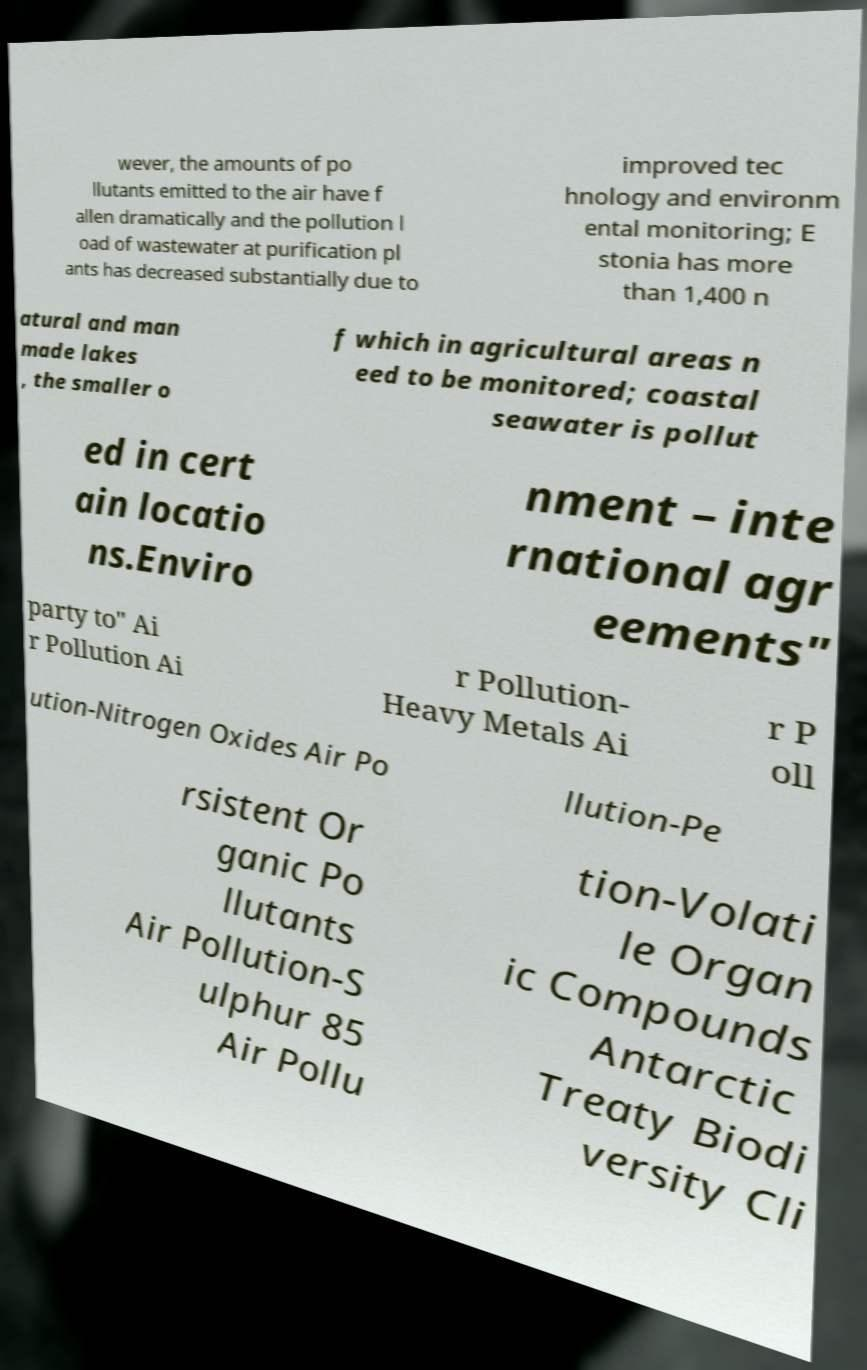There's text embedded in this image that I need extracted. Can you transcribe it verbatim? wever, the amounts of po llutants emitted to the air have f allen dramatically and the pollution l oad of wastewater at purification pl ants has decreased substantially due to improved tec hnology and environm ental monitoring; E stonia has more than 1,400 n atural and man made lakes , the smaller o f which in agricultural areas n eed to be monitored; coastal seawater is pollut ed in cert ain locatio ns.Enviro nment – inte rnational agr eements" party to" Ai r Pollution Ai r Pollution- Heavy Metals Ai r P oll ution-Nitrogen Oxides Air Po llution-Pe rsistent Or ganic Po llutants Air Pollution-S ulphur 85 Air Pollu tion-Volati le Organ ic Compounds Antarctic Treaty Biodi versity Cli 